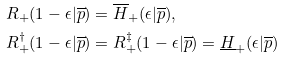Convert formula to latex. <formula><loc_0><loc_0><loc_500><loc_500>& R _ { + } ( 1 - \epsilon | \overline { p } ) = \overline { H } _ { + } ( \epsilon | \overline { p } ) , \\ & R _ { + } ^ { \dagger } ( 1 - \epsilon | \overline { p } ) = R _ { + } ^ { \ddagger } ( 1 - \epsilon | \overline { p } ) = \underline { H } _ { + } ( \epsilon | \overline { p } )</formula> 